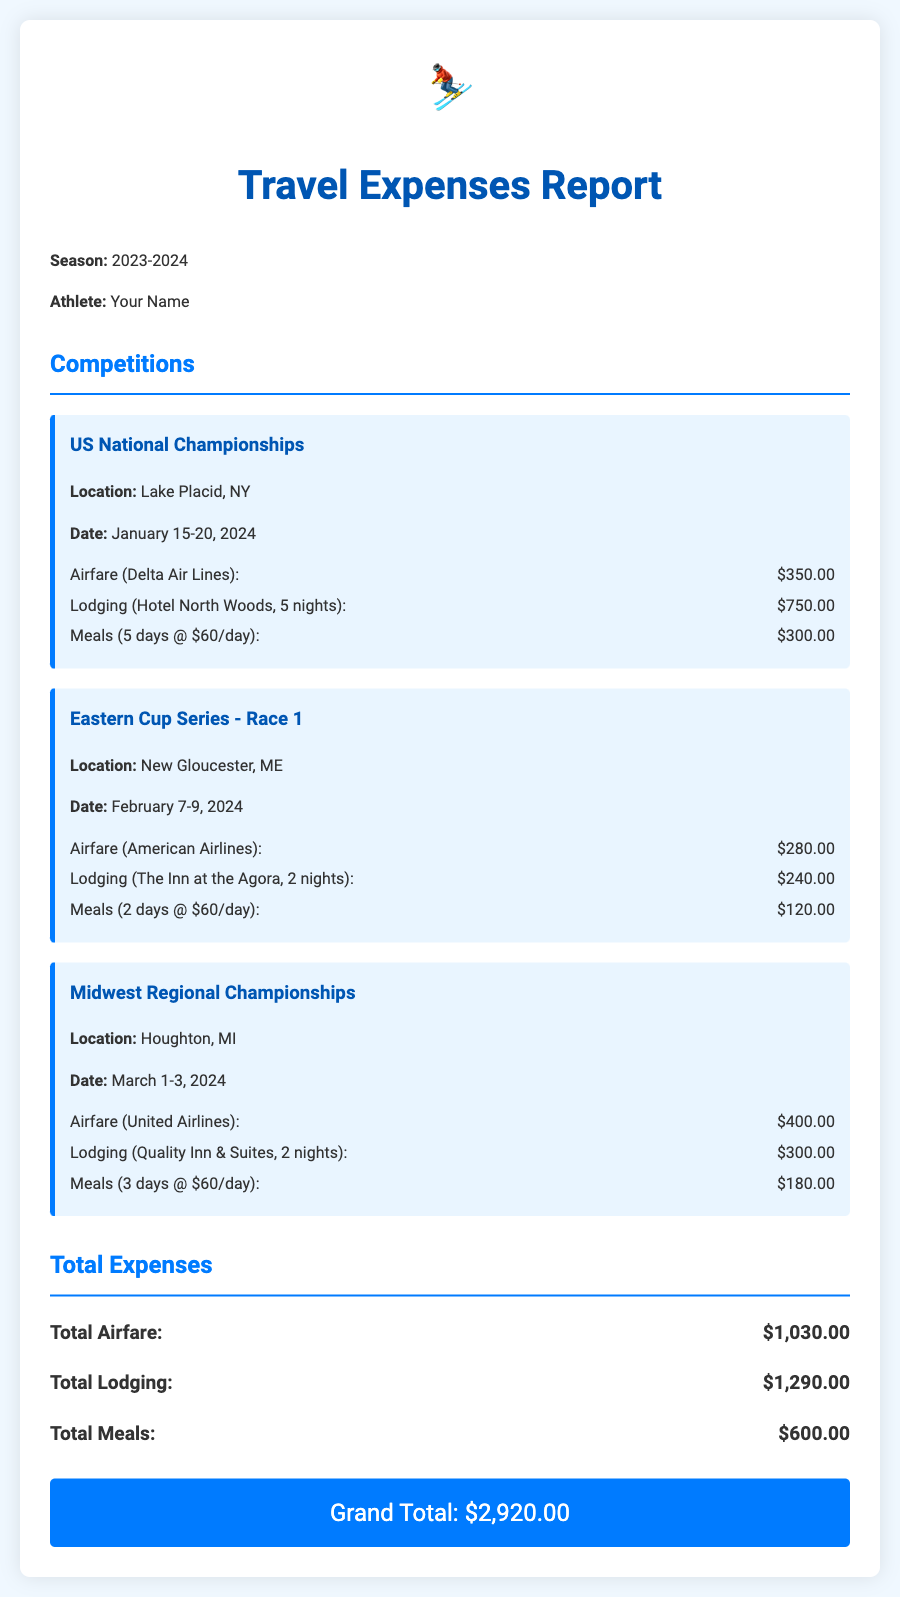What is the total airfare? The total airfare is calculated by summing the airfare costs from all competitions, which are $350.00 + $280.00 + $400.00.
Answer: $1,030.00 What is the location of the US National Championships? The location is explicitly stated in the competition details for the US National Championships.
Answer: Lake Placid, NY How many nights of lodging were booked for the Midwest Regional Championships? The number of nights is detailed in the lodging expense for the Midwest Regional Championships, which is 2 nights.
Answer: 2 nights What is the total cost for meals across all competitions? The total cost for meals is obtained by adding the meals costs from the three competitions, which are $300.00 + $120.00 + $180.00.
Answer: $600.00 When is the Eastern Cup Series - Race 1 scheduled? The date of the Eastern Cup Series - Race 1 is provided in the competition details.
Answer: February 7-9, 2024 What was the lodging cost for the Eastern Cup Series - Race 1? The lodging cost for the Eastern Cup Series - Race 1 is clearly shown in its expense details.
Answer: $240.00 What is the grand total of the travel expenses report? The grand total is given at the end of the report as the sum of all expenses.
Answer: $2,920.00 What airline was used for airfare to the Midwest Regional Championships? The document specifies the airline used for airfare to the Midwest Regional Championships.
Answer: United Airlines What is the daily meal cost mentioned in the report? The daily meal cost can be found in the meals breakdown for the competitions, set at $60 per day.
Answer: $60/day 